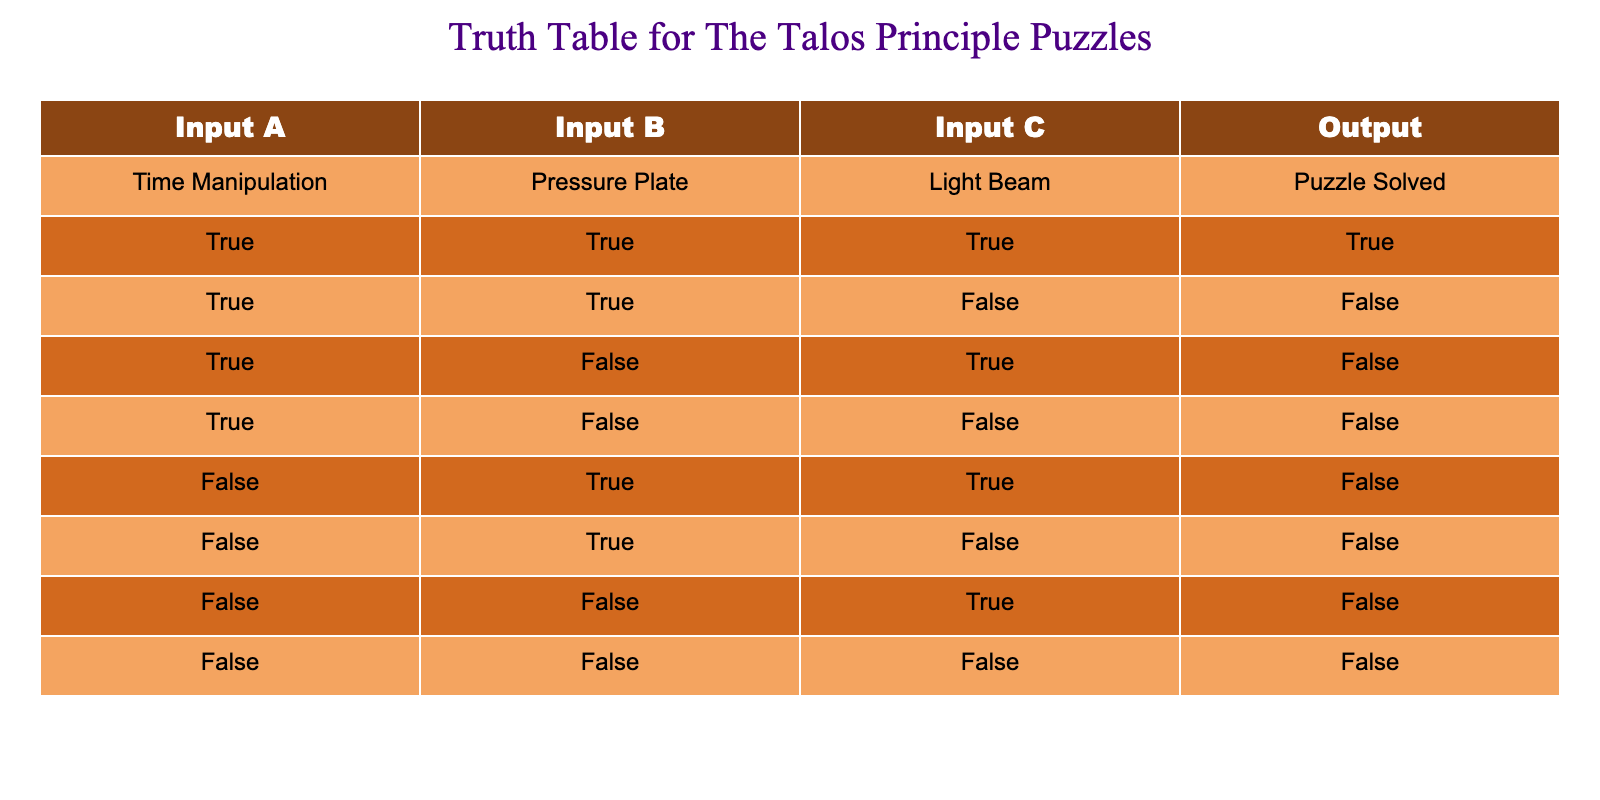What output is produced when all inputs are true? When all inputs (Time Manipulation, Pressure Plate, Light Beam) are true, the Output indicates "Puzzle Solved." This is found in the first row of the table.
Answer: True Is it possible to solve the puzzle with only the Light Beam activated? Looking at the table, there are no scenarios where only the Light Beam is true (Input C) and the other inputs are false (Input A and Input B). The relevant rows show that without activating Input A and Input B, the Output will always be false.
Answer: No How many arrangements lead to a puzzle being solved? From the table, only the first row has the Output as true. Therefore, there is only one arrangement of inputs that leads to a puzzle being solved.
Answer: 1 What are the inputs needed to solve the puzzle? The table shows that all three inputs must be true (Time Manipulation, Pressure Plate, and Light Beam) in order for the Output to be "Puzzle Solved," which is only found in the first row.
Answer: All three inputs must be true If Time Manipulation is false, what is the output when Pressure Plate and Light Beam are true? The table indicates that with Time Manipulation as false and both Pressure Plate and Light Beam as true, the Output remains false. This is observed in the fifth row.
Answer: False What is the count of rows resulting in a "Puzzle Solved" output? Upon examining the Output column in the table, there is only one row where the Output is true, meaning the puzzle is solved.
Answer: 1 Do any configurations where Time Manipulation is true but the puzzle is not solved? The table defines that with Time Manipulation as true, two out of the three configurations lead to puzzles not being solved (second and third rows). Therefore, there are configurations where this condition is met.
Answer: Yes What happens when only the Pressure Plate and Light Beam are true, and Time Manipulation is false? According to the table, when Time Manipulation is false, and both Pressure Plate and Light Beam are true, the Output is false, as shown in the fifth row.
Answer: False How many combinations exist where Time Manipulation is true but other inputs do not solve the puzzle? The table shows that there are two combinations (rows two and three) where Time Manipulation is true but do not lead to a puzzle solved.
Answer: 2 